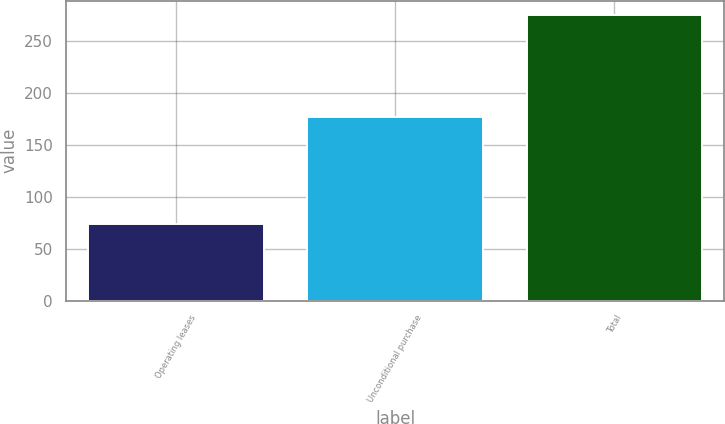Convert chart to OTSL. <chart><loc_0><loc_0><loc_500><loc_500><bar_chart><fcel>Operating leases<fcel>Unconditional purchase<fcel>Total<nl><fcel>74<fcel>177<fcel>275<nl></chart> 